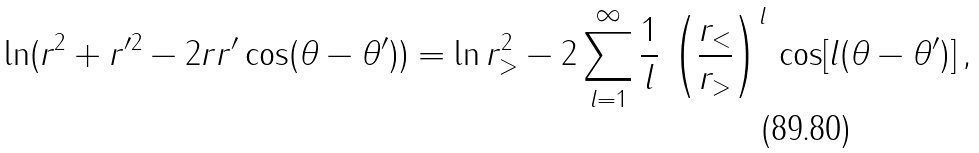<formula> <loc_0><loc_0><loc_500><loc_500>\ln ( r ^ { 2 } + r ^ { \prime 2 } - 2 r r ^ { \prime } \cos ( \theta - \theta ^ { \prime } ) ) = \ln r _ { > } ^ { 2 } - 2 \sum _ { l = 1 } ^ { \infty } \frac { 1 } { l } \, \left ( \frac { r _ { < } } { r _ { > } } \right ) ^ { l } \, \cos [ l ( \theta - \theta ^ { \prime } ) ] \, ,</formula> 